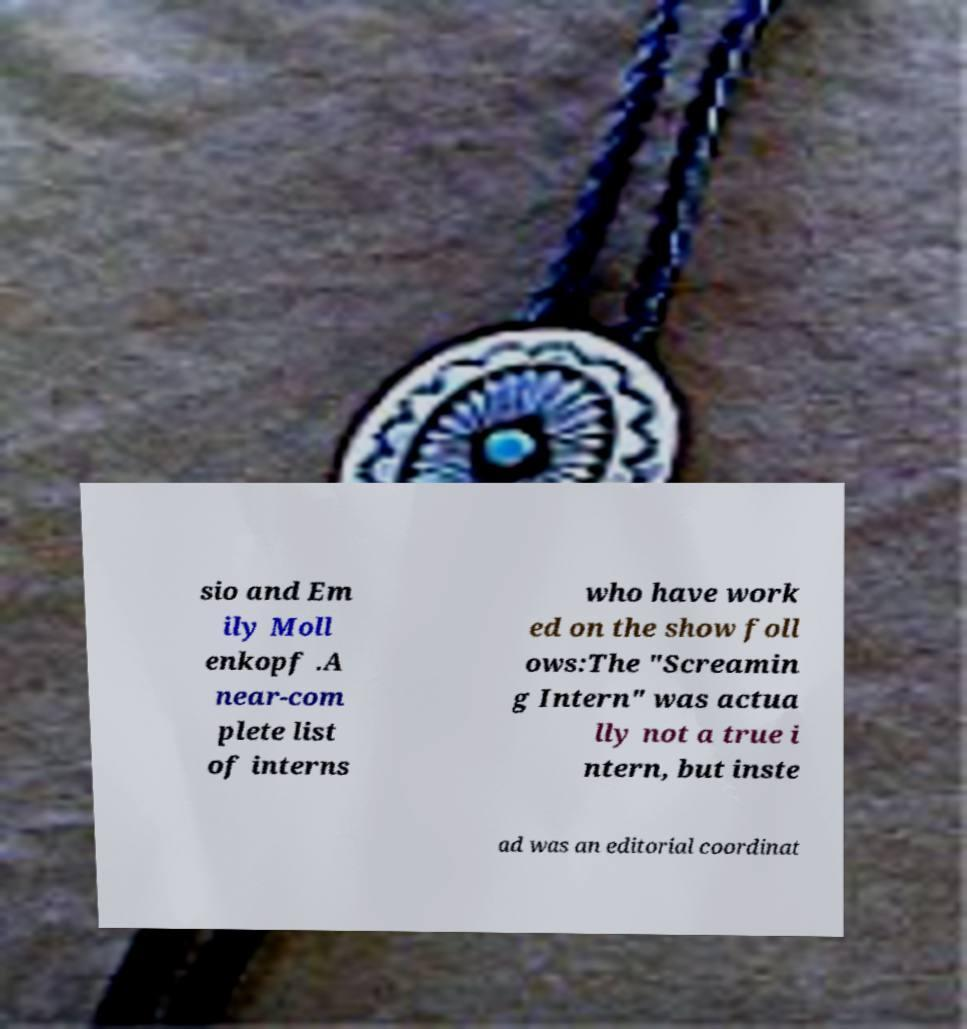Can you accurately transcribe the text from the provided image for me? sio and Em ily Moll enkopf .A near-com plete list of interns who have work ed on the show foll ows:The "Screamin g Intern" was actua lly not a true i ntern, but inste ad was an editorial coordinat 